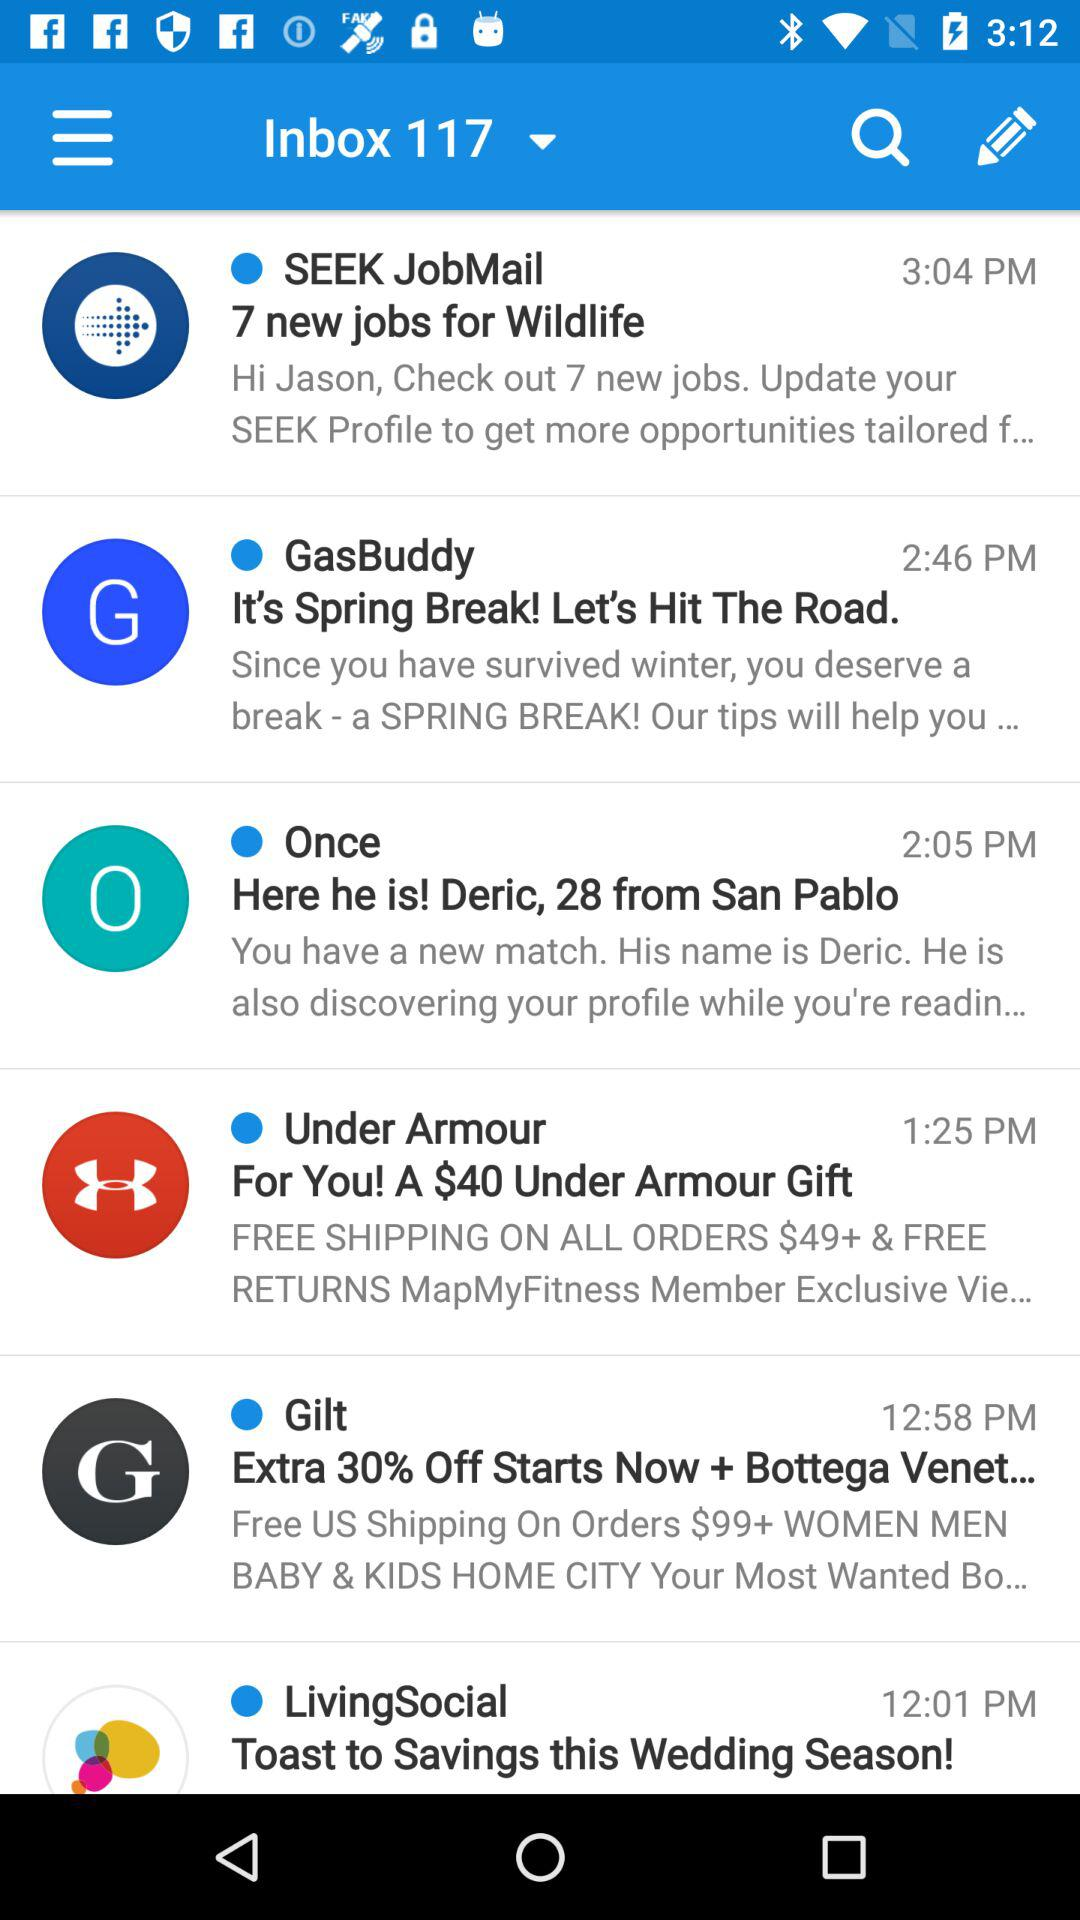How many emails are there in the inbox? There are 117 emails. 